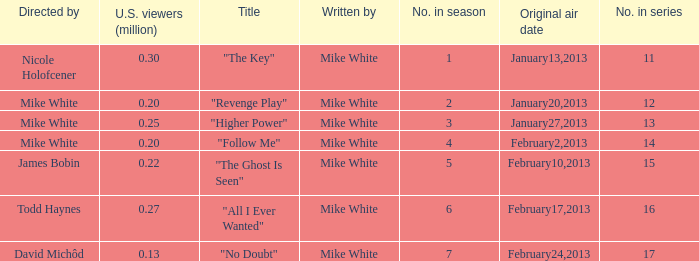Who directed the episode that have 0.25 million u.s viewers Mike White. 